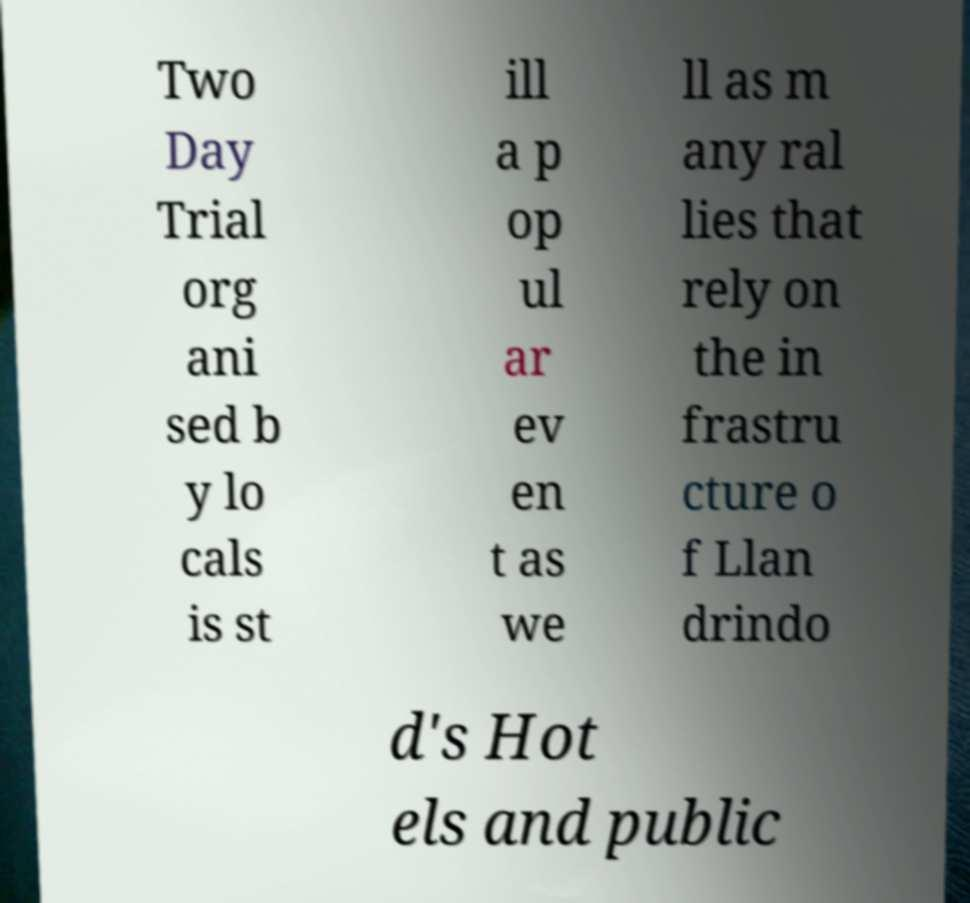Can you accurately transcribe the text from the provided image for me? Two Day Trial org ani sed b y lo cals is st ill a p op ul ar ev en t as we ll as m any ral lies that rely on the in frastru cture o f Llan drindo d's Hot els and public 